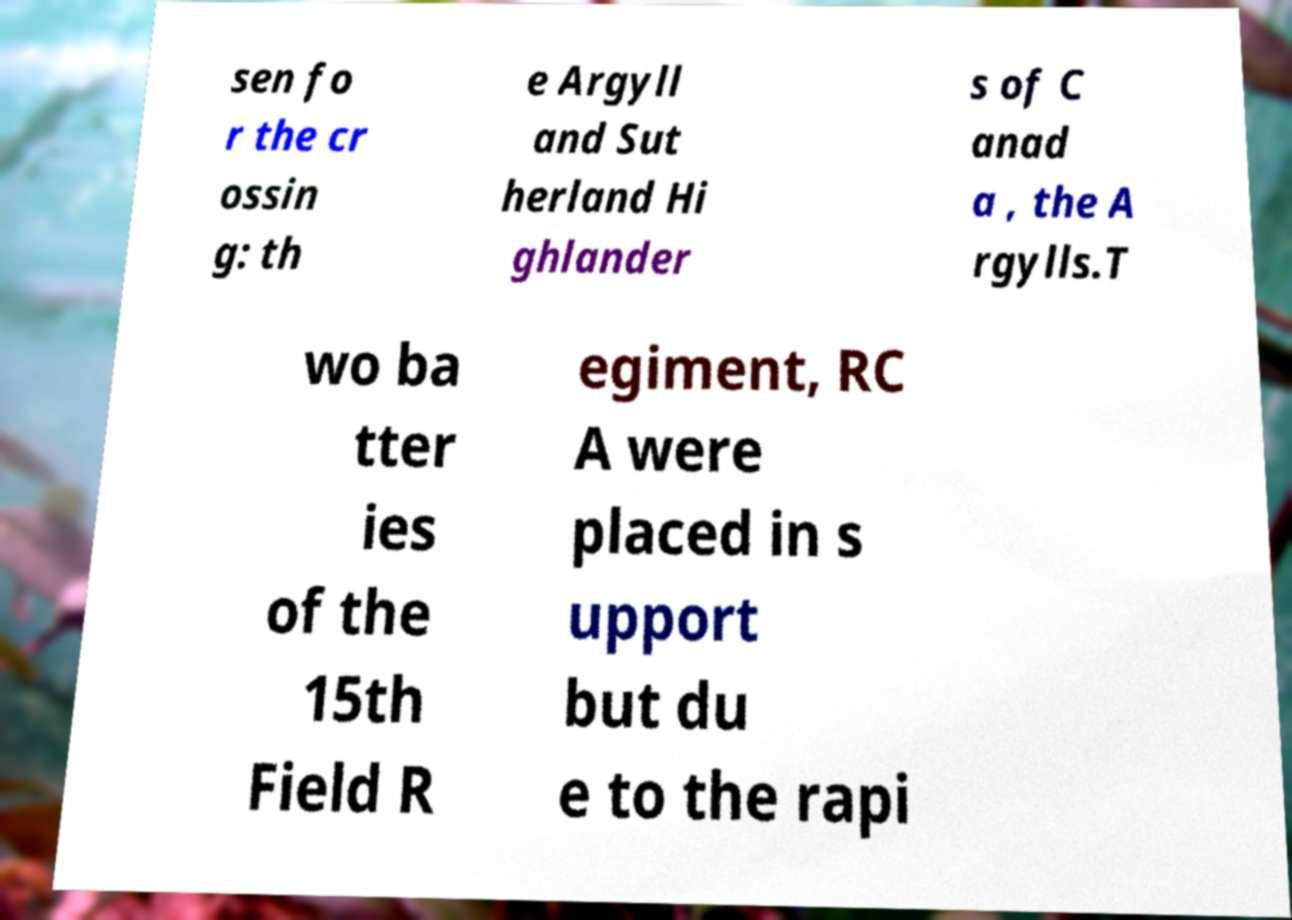Please read and relay the text visible in this image. What does it say? sen fo r the cr ossin g: th e Argyll and Sut herland Hi ghlander s of C anad a , the A rgylls.T wo ba tter ies of the 15th Field R egiment, RC A were placed in s upport but du e to the rapi 